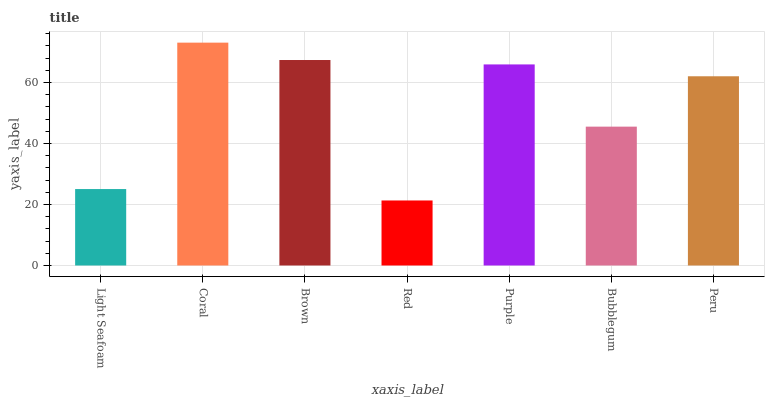Is Red the minimum?
Answer yes or no. Yes. Is Coral the maximum?
Answer yes or no. Yes. Is Brown the minimum?
Answer yes or no. No. Is Brown the maximum?
Answer yes or no. No. Is Coral greater than Brown?
Answer yes or no. Yes. Is Brown less than Coral?
Answer yes or no. Yes. Is Brown greater than Coral?
Answer yes or no. No. Is Coral less than Brown?
Answer yes or no. No. Is Peru the high median?
Answer yes or no. Yes. Is Peru the low median?
Answer yes or no. Yes. Is Brown the high median?
Answer yes or no. No. Is Purple the low median?
Answer yes or no. No. 